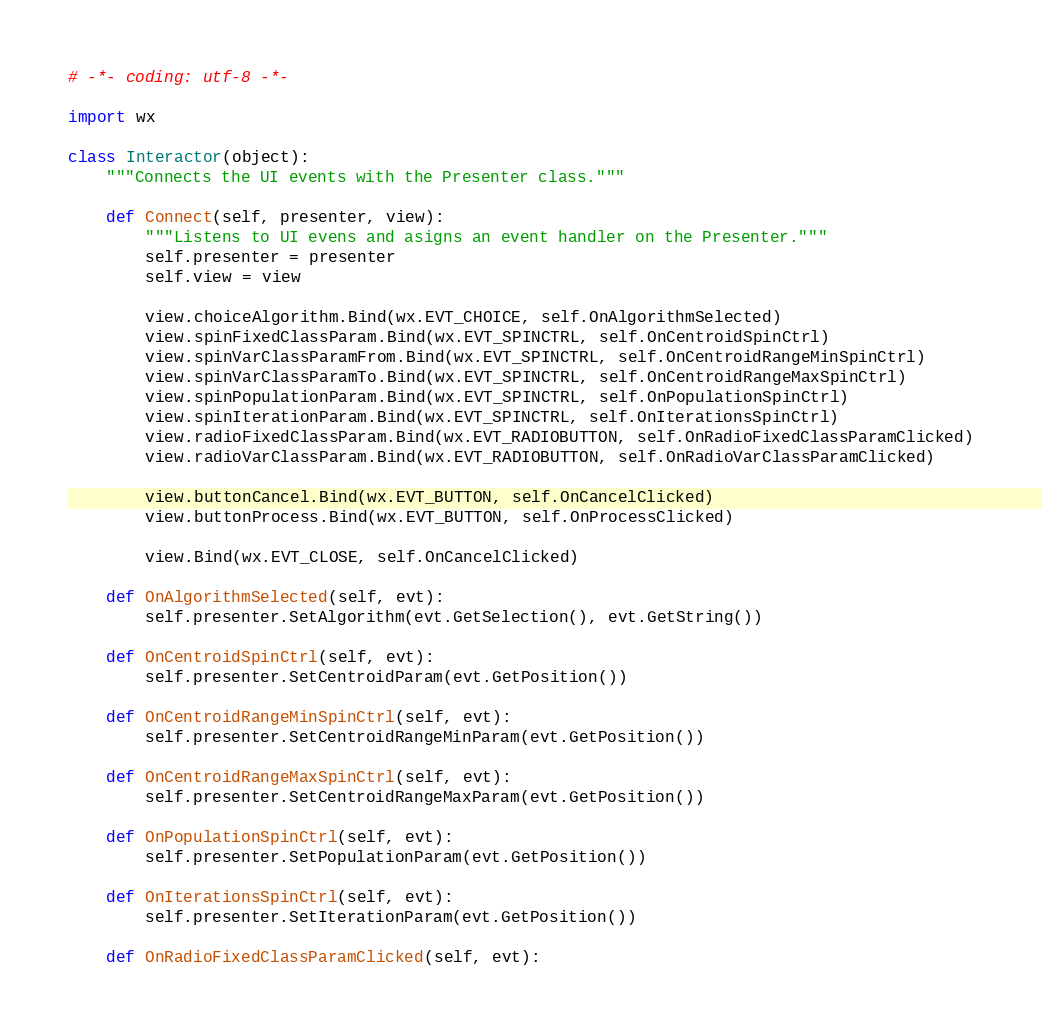<code> <loc_0><loc_0><loc_500><loc_500><_Python_># -*- coding: utf-8 -*-

import wx

class Interactor(object):
    """Connects the UI events with the Presenter class."""

    def Connect(self, presenter, view):
        """Listens to UI evens and asigns an event handler on the Presenter."""
        self.presenter = presenter
        self.view = view

        view.choiceAlgorithm.Bind(wx.EVT_CHOICE, self.OnAlgorithmSelected)
        view.spinFixedClassParam.Bind(wx.EVT_SPINCTRL, self.OnCentroidSpinCtrl)
        view.spinVarClassParamFrom.Bind(wx.EVT_SPINCTRL, self.OnCentroidRangeMinSpinCtrl)
        view.spinVarClassParamTo.Bind(wx.EVT_SPINCTRL, self.OnCentroidRangeMaxSpinCtrl)
        view.spinPopulationParam.Bind(wx.EVT_SPINCTRL, self.OnPopulationSpinCtrl)
        view.spinIterationParam.Bind(wx.EVT_SPINCTRL, self.OnIterationsSpinCtrl)
        view.radioFixedClassParam.Bind(wx.EVT_RADIOBUTTON, self.OnRadioFixedClassParamClicked)
        view.radioVarClassParam.Bind(wx.EVT_RADIOBUTTON, self.OnRadioVarClassParamClicked)

        view.buttonCancel.Bind(wx.EVT_BUTTON, self.OnCancelClicked)
        view.buttonProcess.Bind(wx.EVT_BUTTON, self.OnProcessClicked)

        view.Bind(wx.EVT_CLOSE, self.OnCancelClicked)

    def OnAlgorithmSelected(self, evt):
        self.presenter.SetAlgorithm(evt.GetSelection(), evt.GetString())

    def OnCentroidSpinCtrl(self, evt):
        self.presenter.SetCentroidParam(evt.GetPosition())

    def OnCentroidRangeMinSpinCtrl(self, evt):
        self.presenter.SetCentroidRangeMinParam(evt.GetPosition())

    def OnCentroidRangeMaxSpinCtrl(self, evt):
        self.presenter.SetCentroidRangeMaxParam(evt.GetPosition())

    def OnPopulationSpinCtrl(self, evt):
        self.presenter.SetPopulationParam(evt.GetPosition())

    def OnIterationsSpinCtrl(self, evt):
        self.presenter.SetIterationParam(evt.GetPosition())

    def OnRadioFixedClassParamClicked(self, evt):</code> 